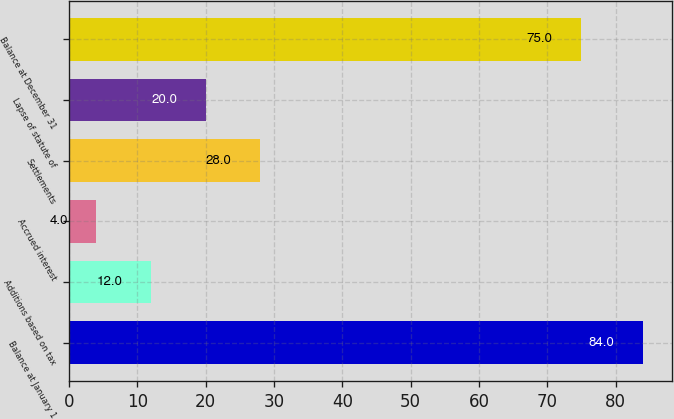Convert chart. <chart><loc_0><loc_0><loc_500><loc_500><bar_chart><fcel>Balance at January 1<fcel>Additions based on tax<fcel>Accrued interest<fcel>Settlements<fcel>Lapse of statute of<fcel>Balance at December 31<nl><fcel>84<fcel>12<fcel>4<fcel>28<fcel>20<fcel>75<nl></chart> 